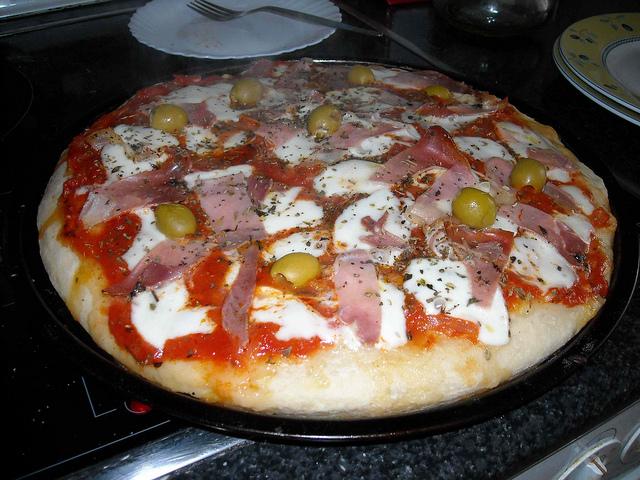Has anyone eaten this pizza yet?
Be succinct. No. What are the green things on the food?
Give a very brief answer. Olives. How many plates are visible in the picture?
Keep it brief. 3. What are the red stripes on the pizza?
Give a very brief answer. Ham. 